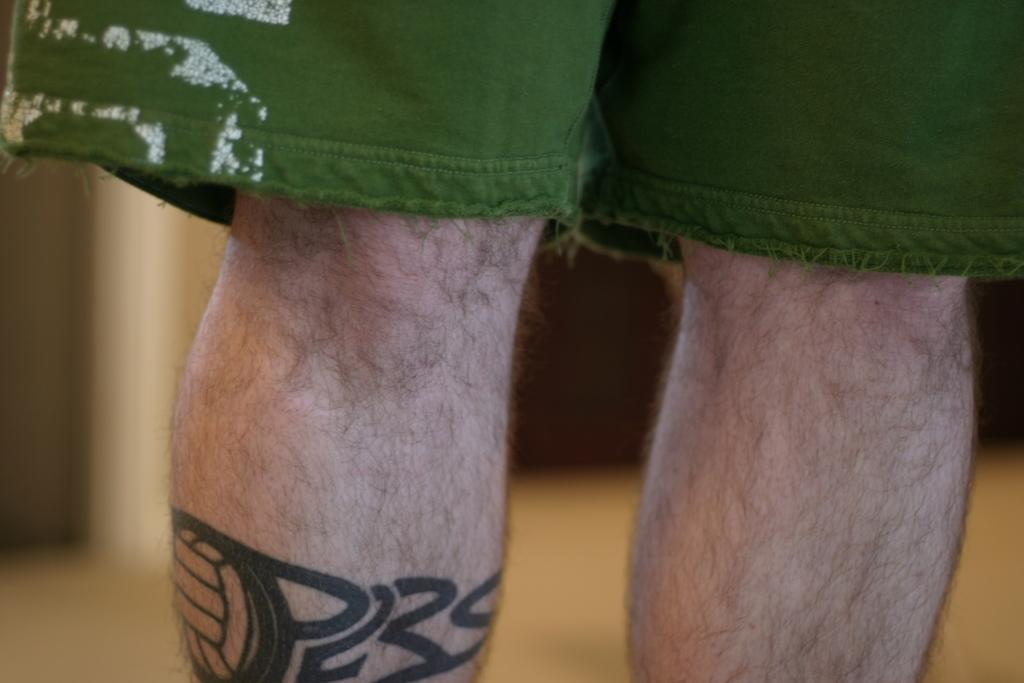What is visible in the foreground of the image? There are legs of a person in the foreground of the image. What is the person wearing in the image? There is a short visible in the image. Can you describe any distinguishing features on the person's leg? The person's leg has a tattoo. How would you describe the background of the image? The background of the image is blurred. What type of bun is being held by the person in the image? There is no bun visible in the image; only the person's legs and a short are present. How many lines can be seen on the beetle in the image? There is no beetle present in the image. 